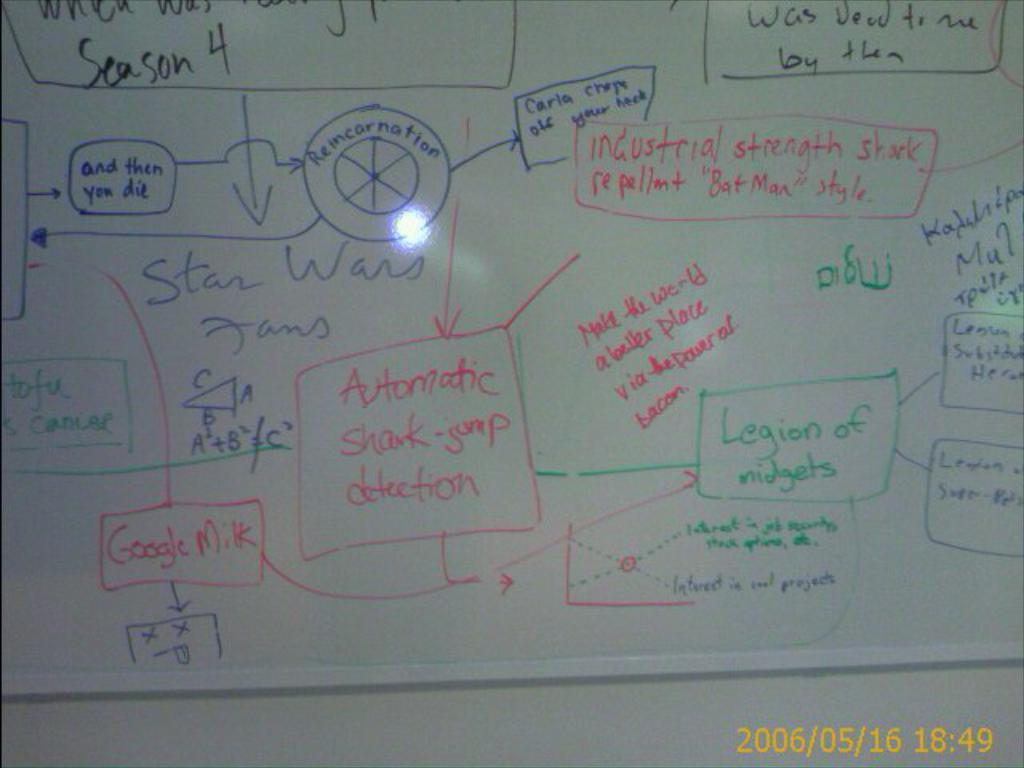<image>
Relay a brief, clear account of the picture shown. A white board has a flow chart wrote out on it that is about Star Wars fans. 